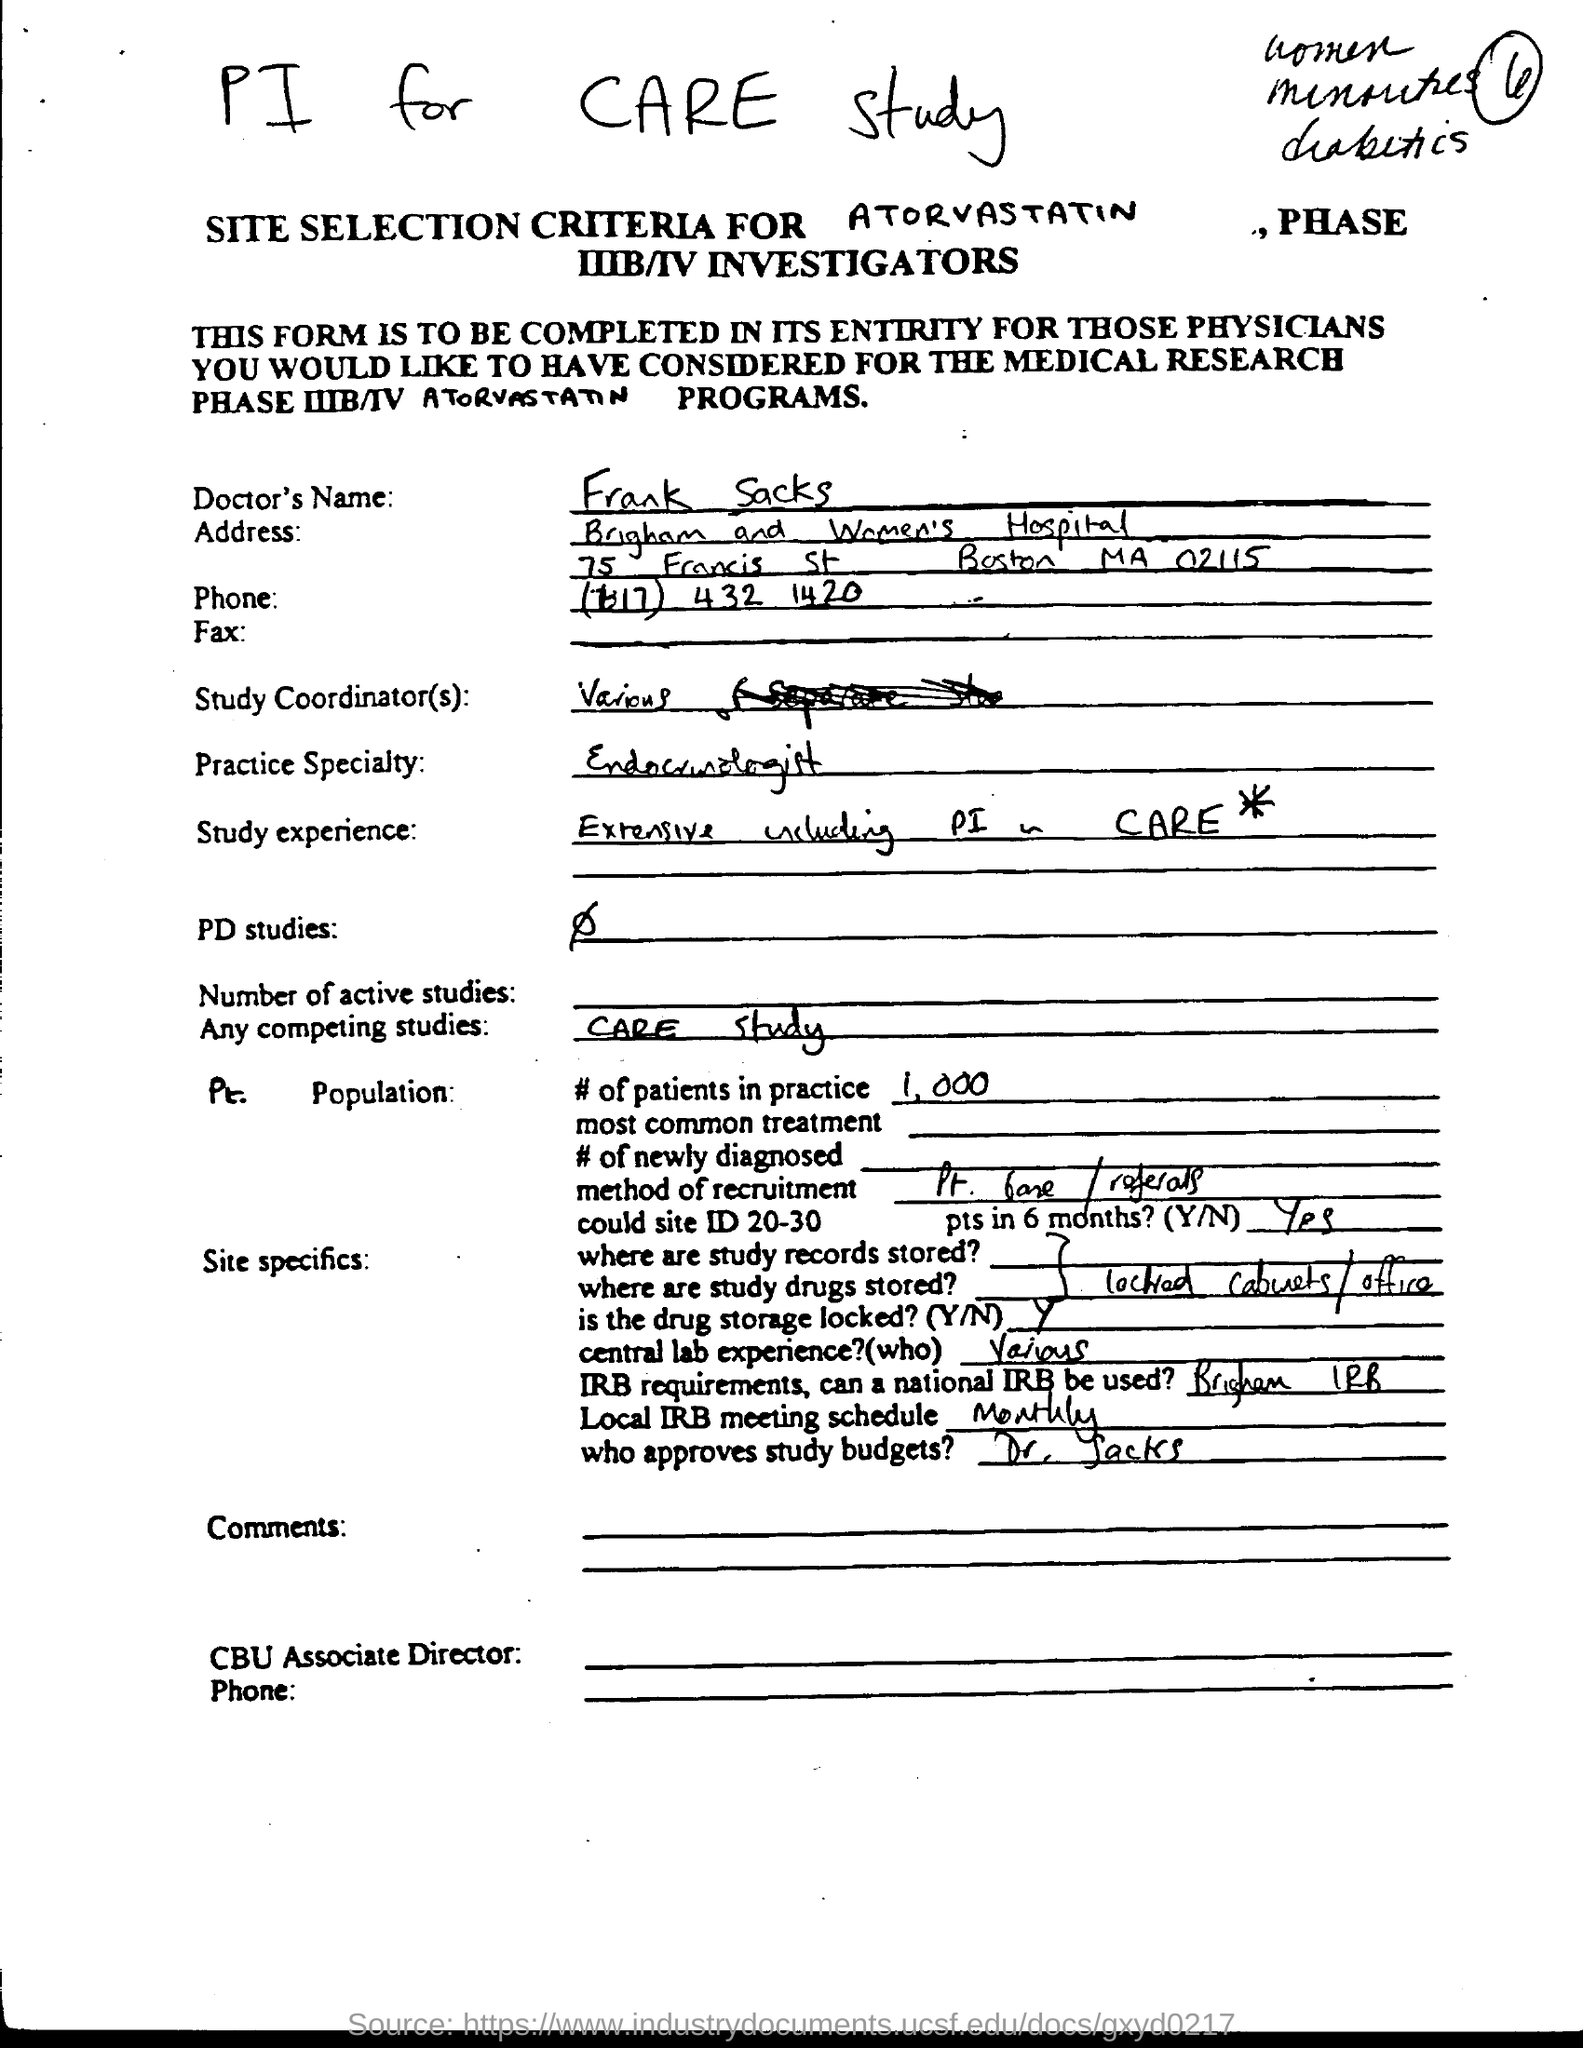Specify some key components in this picture. The approval of study budgets is approved by Dr. Sacks. The Doctor's practice specialty is endocrinology. The Doctor's name is Frank Sacks. 